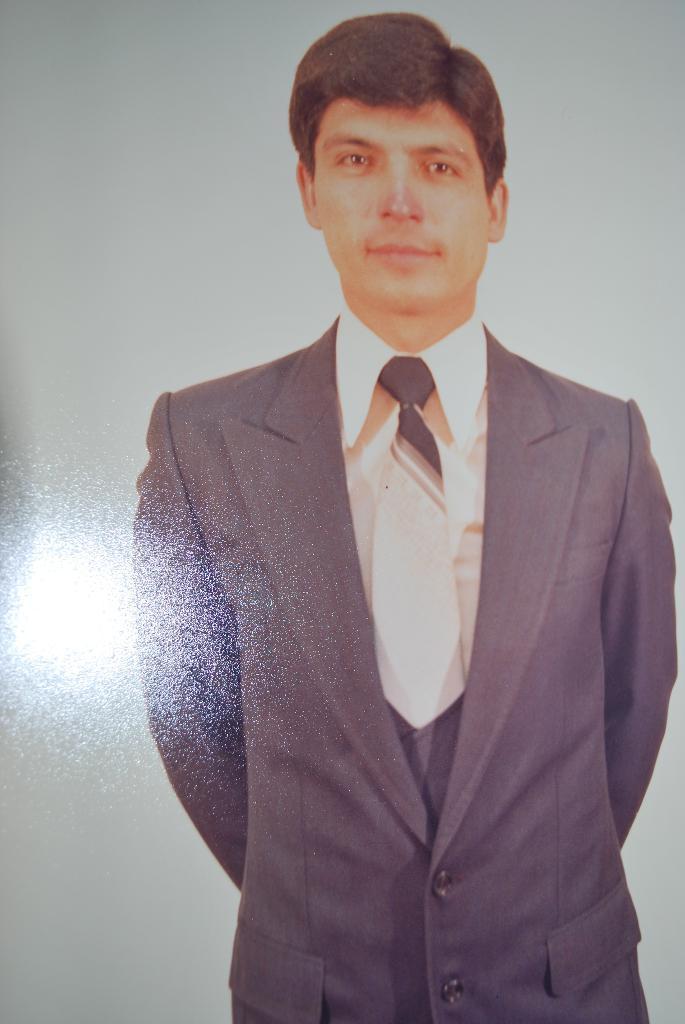In one or two sentences, can you explain what this image depicts? In this image I can see a person wearing white shirt, white and black tie and black blazer is standing and I can see the white background. 